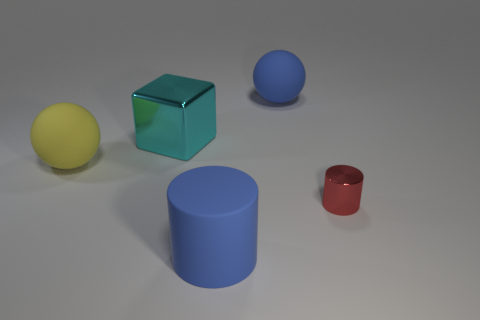Add 2 tiny gray metallic blocks. How many objects exist? 7 Subtract all blocks. How many objects are left? 4 Add 4 big blue matte cylinders. How many big blue matte cylinders are left? 5 Add 2 cylinders. How many cylinders exist? 4 Subtract 1 blue cylinders. How many objects are left? 4 Subtract all yellow things. Subtract all large blue matte spheres. How many objects are left? 3 